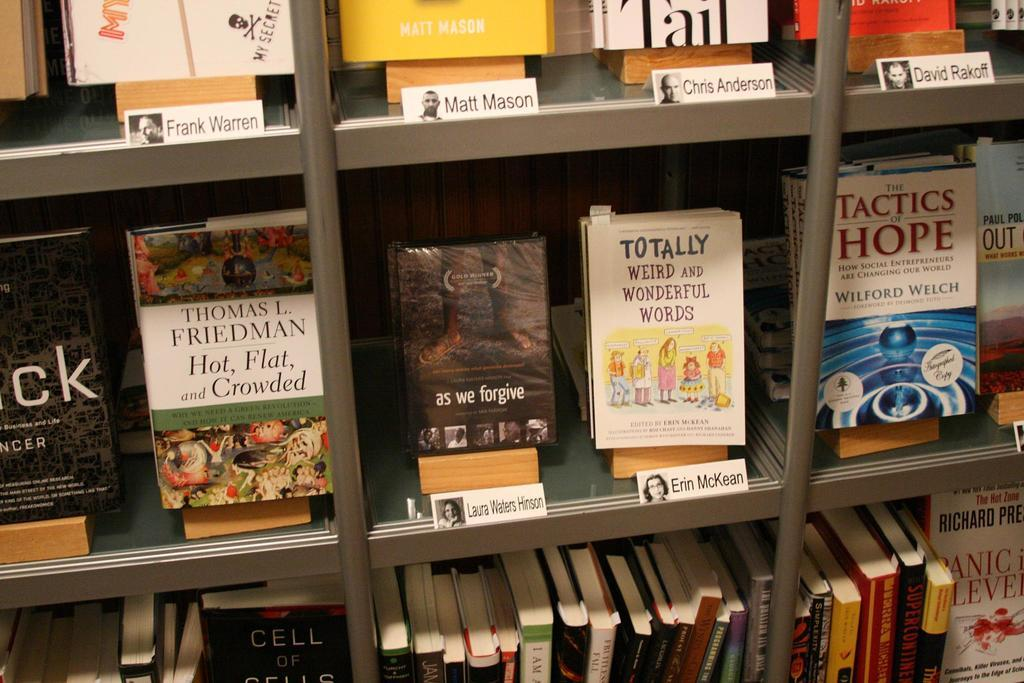What type of furniture is present in the image? There is a cupboard with shelves in the image. What can be found on the shelves of the cupboard? The shelves contain books. What else is stored inside the cupboard? There are white cards with names and images inside the cupboard. How does the wind affect the books on the shelves in the image? There is no wind present in the image, so the books on the shelves are not affected by it. 